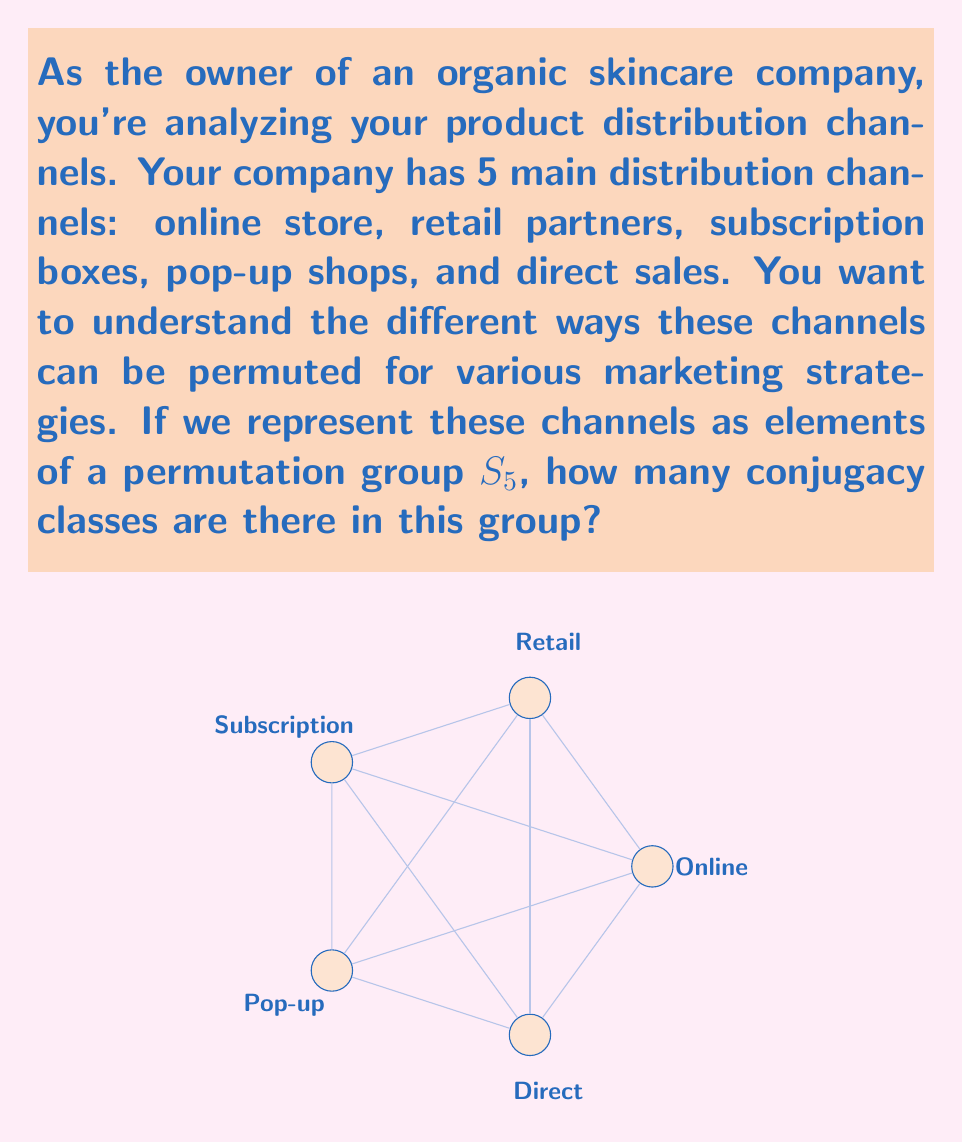What is the answer to this math problem? To solve this problem, we need to understand that the number of conjugacy classes in the symmetric group $S_n$ is equal to the number of distinct cycle structures, which is the same as the number of integer partitions of $n$.

For $S_5$, we need to find all the ways to partition the number 5:

1. $5 = 5$ (one 5-cycle)
2. $5 = 4 + 1$ (one 4-cycle and one 1-cycle)
3. $5 = 3 + 2$ (one 3-cycle and one 2-cycle)
4. $5 = 3 + 1 + 1$ (one 3-cycle and two 1-cycles)
5. $5 = 2 + 2 + 1$ (two 2-cycles and one 1-cycle)
6. $5 = 2 + 1 + 1 + 1$ (one 2-cycle and three 1-cycles)
7. $5 = 1 + 1 + 1 + 1 + 1$ (five 1-cycles, identity permutation)

Each of these partitions represents a distinct conjugacy class in $S_5$. 

In the context of distribution channels:
1. represents a complete cycle of all channels
2. represents a cycle of 4 channels with 1 fixed
3. represents a cycle of 3 channels and a swap of 2
4. represents a cycle of 3 channels with 2 fixed
5. represents two separate swaps with 1 fixed
6. represents a single swap with 3 fixed
7. represents no changes (identity)

Therefore, there are 7 conjugacy classes in $S_5$, corresponding to 7 distinct ways to permute the distribution channels.
Answer: 7 